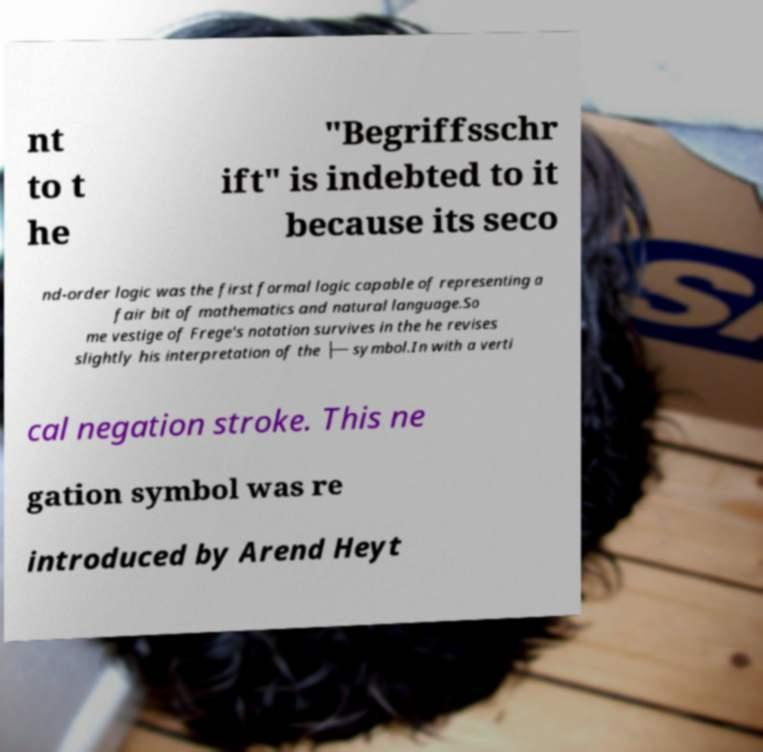What messages or text are displayed in this image? I need them in a readable, typed format. nt to t he "Begriffsschr ift" is indebted to it because its seco nd-order logic was the first formal logic capable of representing a fair bit of mathematics and natural language.So me vestige of Frege's notation survives in the he revises slightly his interpretation of the ├─ symbol.In with a verti cal negation stroke. This ne gation symbol was re introduced by Arend Heyt 